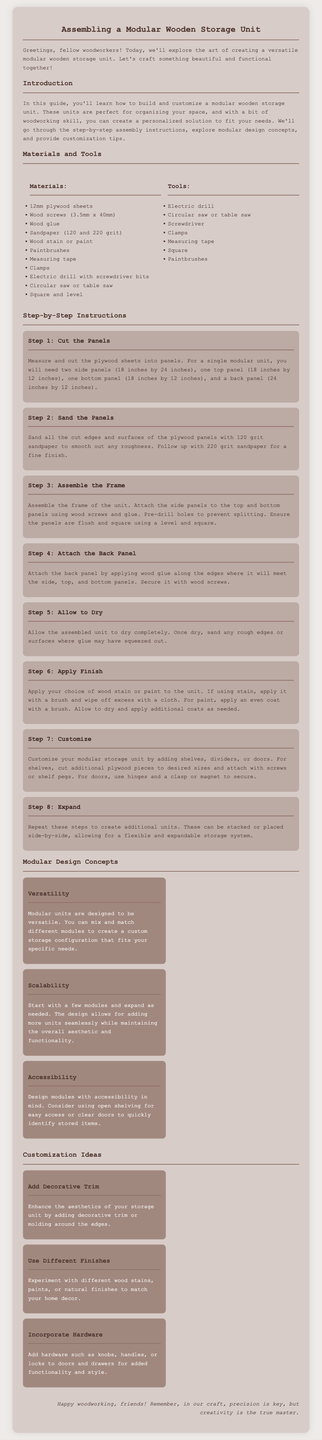What type of wood is recommended for the storage unit? The materials section specifies using 12mm plywood sheets for constructing the storage unit.
Answer: 12mm plywood sheets How many steps are included in the assembly instructions? The step-by-step instructions section outlines a total of eight steps for assembling the unit.
Answer: 8 What tools are suggested for cutting the panels? The tools section includes a circular saw or table saw for cutting the plywood panels.
Answer: Circular saw or table saw Which step involves customizing the storage unit? Step 7 of the instructions is specifically dedicated to customizing the storage unit by adding shelves, dividers, or doors.
Answer: Step 7 What is one aspect of modular design concepts mentioned in the document? One of the concepts mentioned is "Versatility," which indicates the ability to mix and match different modules.
Answer: Versatility What should you do after you allow the unit to dry? After allowing the assembled unit to dry, you should sand any rough edges or surfaces where glue may have squeezed out.
Answer: Sand any rough edges What are the recommended sandpaper grits for finishing the panels? The instructions suggest using 120 grit and 220 grit sandpaper for smoothing the panels.
Answer: 120 grit and 220 grit How can you expand your modular storage system? The document advises that you can repeat the assembly steps to create additional units that can be stacked or placed side-by-side.
Answer: Stack or place side-by-side 